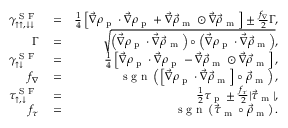Convert formula to latex. <formula><loc_0><loc_0><loc_500><loc_500>\begin{array} { r l r } { \gamma _ { \uparrow \uparrow , \downarrow \downarrow } ^ { S F } } & = } & { \frac { 1 } { 4 } \left [ \vec { \nabla } \rho _ { p } \cdot \vec { \nabla } \rho _ { p } + \vec { \nabla } \vec { \rho } _ { m } \odot \vec { \nabla } \vec { \rho } _ { m } \right ] \pm \frac { f _ { \nabla } } { 2 } \Gamma , } \\ { \Gamma } & = } & { \sqrt { \left ( \vec { \nabla } \rho _ { p } \cdot \vec { \nabla } \vec { \rho } _ { m } \right ) \circ \left ( \vec { \nabla } \rho _ { p } \cdot \vec { \nabla } \vec { \rho } _ { m } \right ) } , } \\ { \gamma _ { \uparrow \downarrow } ^ { S F } } & = } & { \frac { 1 } { 4 } \left [ \vec { \nabla } \rho _ { p } \cdot \vec { \nabla } \rho _ { p } - \vec { \nabla } \vec { \rho } _ { m } \odot \vec { \nabla } \vec { \rho } _ { m } \right ] , } \\ { f _ { \nabla } } & = } & { s g n \left ( \left [ \vec { \nabla } \rho _ { p } \cdot \vec { \nabla } \vec { \rho } _ { m } \right ] \circ \vec { \rho } _ { m } \right ) , } \\ { \tau _ { \uparrow , \downarrow } ^ { S F } } & = } & { \frac { 1 } { 2 } \tau _ { p } \pm \frac { f _ { \tau } } { 2 } | \vec { \tau } _ { m } | , } \\ { f _ { \tau } } & = } & { s g n \left ( \vec { \tau } _ { m } \circ \vec { \rho } _ { m } \right ) . } \end{array}</formula> 